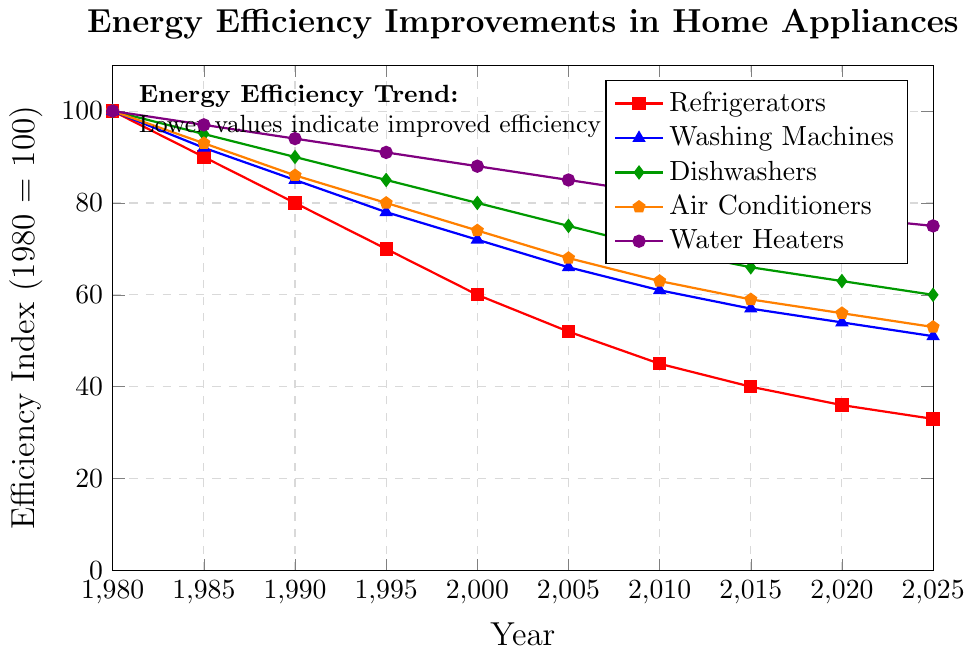Which device category shows the highest efficiency improvement over the period 1980-2025? To find the device category with the highest efficiency improvement, we need to identify the category with the lowest efficiency index in 2025. From the plot, Refrigerators have the lowest index at 33 in 2025.
Answer: Refrigerators How did the energy efficiency of dishwashers change from 1980 to 1995? Compare the efficiency index of dishwashers in 1980 and 1995. In 1980, the index is 100, and in 1995, it is 85. The difference is 100 - 85 = 15 points. This indicates an improvement.
Answer: Improved by 15 points Which two device categories have the closest efficiency index values in 2020? Compare the efficiency index values for all device categories in 2020: Refrigerators (36), Washing Machines (54), Dishwashers (63), Air Conditioners (56), and Water Heaters (77). The closest values are 56 (Air Conditioners) and 63 (Dishwashers), with a difference of 7 points.
Answer: Dishwashers and Air Conditioners What is the average efficiency index of Washing Machines over the period 1980-2025? To calculate the average, sum the efficiency indices for Washing Machines from 1980-2025, and divide by the number of years: (100 + 92 + 85 + 78 + 72 + 66 + 61 + 57 + 54 + 51) / 10 = 71.6.
Answer: 71.6 By how much did the efficiency index of Air Conditioners improve between 1980 and 2000? Compare the efficiency index of Air Conditioners in 1980 and 2000. In 1980, the index is 100, and in 2000, it is 74. The difference is 100 - 74 = 26 points.
Answer: 26 points Which device category shows the least improvement in energy efficiency from 1980 to 2025? To identify the category with the least improvement, find the highest efficiency index in 2025. The Water Heaters have the highest index at 75.
Answer: Water Heaters How does the trend of Washing Machines' efficiency index from 1985 to 1995 compare to that of Air Conditioners within the same timeframe? Compare the changes in efficiency indices from 1985 to 1995 for both categories: Washing Machines: 92 (1985) to 78 (1995), a decrease of 14 points. Air Conditioners: 93 (1985) to 80 (1995), a decrease of 13 points. Washing Machines improved slightly more (by 1 point) than Air Conditioners.
Answer: Washing Machines improved slightly more What is the difference in the efficiency index between the least and most efficient appliance in 2025? Identify the least (Refrigerators at 33) and most efficient (Water Heaters at 75) appliances in 2025 and calculate their difference: 75 - 33 = 42 points.
Answer: 42 points Which device category shows a consistent rate of improvement in efficiency, and how can you tell? Compare the plot lines visually to identify the one with the most linear decline. The Washing Machines’ curve shows a nearly linear decline indicating a consistent rate of improvement.
Answer: Washing Machines 